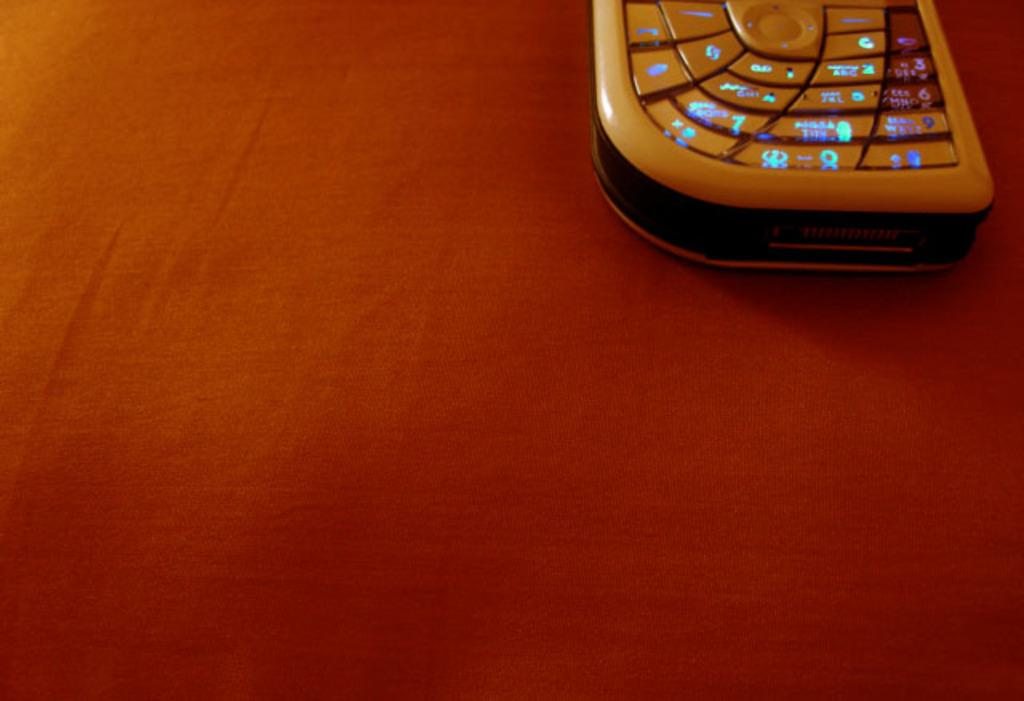What object is hanging in the image? There is a mobile in the image. Where is the mobile located? The mobile is kept on a table. What is covering the table in the image? The table is covered with a red cloth. What type of pocket can be seen on the mobile in the image? There is no pocket present on the mobile in the image. What type of mineral is used to make the mobile in the image? The image does not provide information about the materials used to make the mobile. 